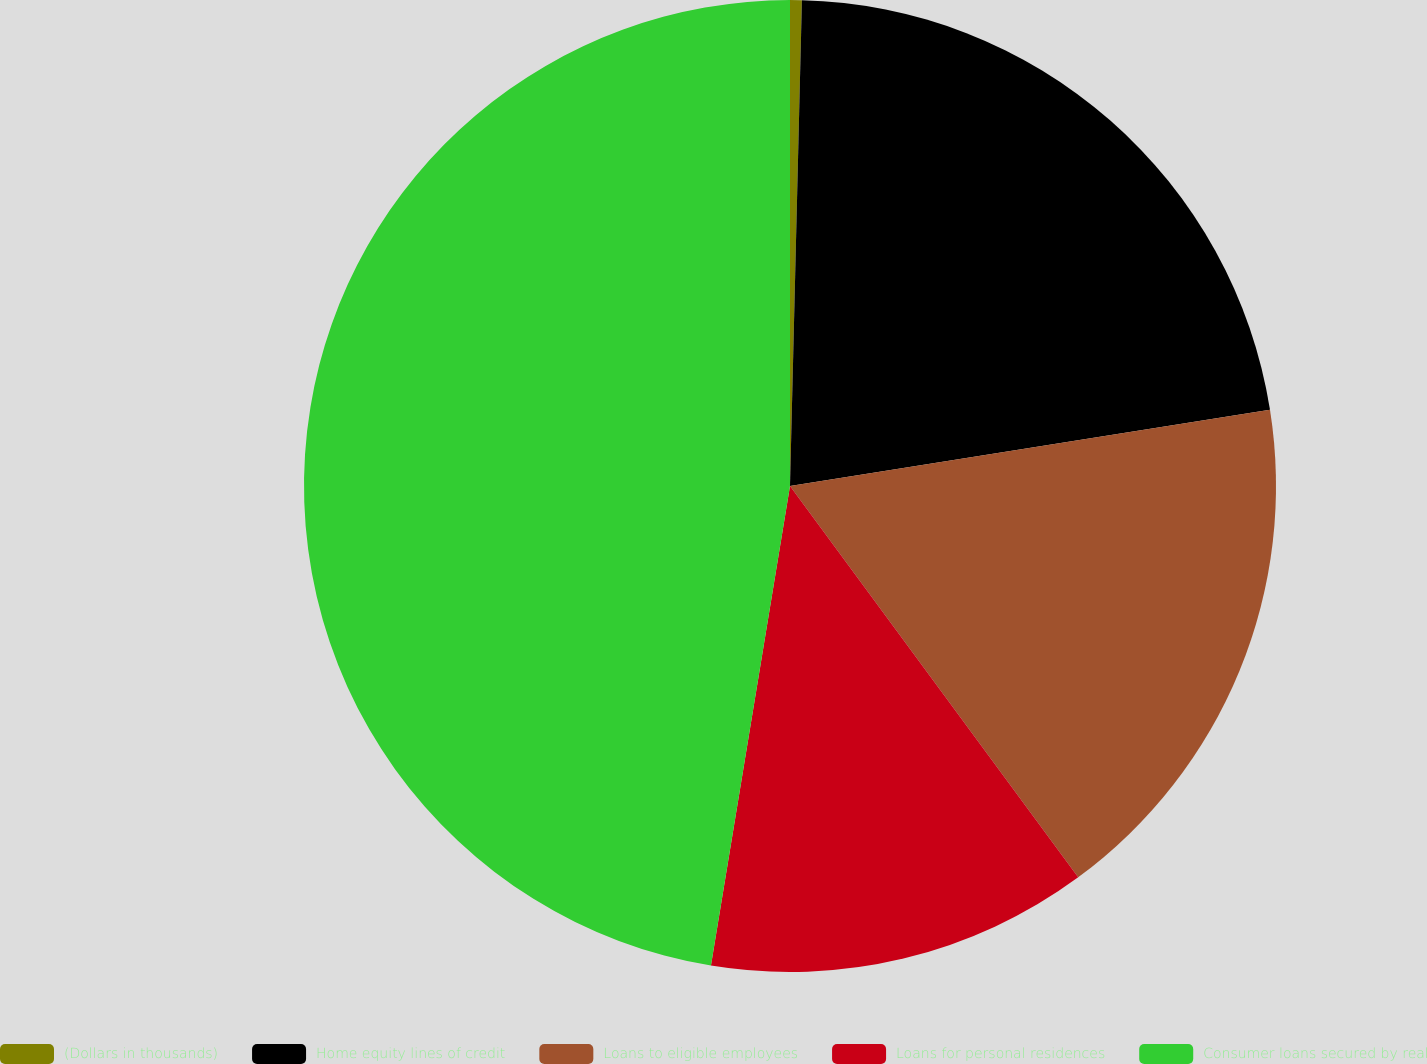Convert chart. <chart><loc_0><loc_0><loc_500><loc_500><pie_chart><fcel>(Dollars in thousands)<fcel>Home equity lines of credit<fcel>Loans to eligible employees<fcel>Loans for personal residences<fcel>Consumer loans secured by real<nl><fcel>0.39%<fcel>22.1%<fcel>17.4%<fcel>12.7%<fcel>47.39%<nl></chart> 